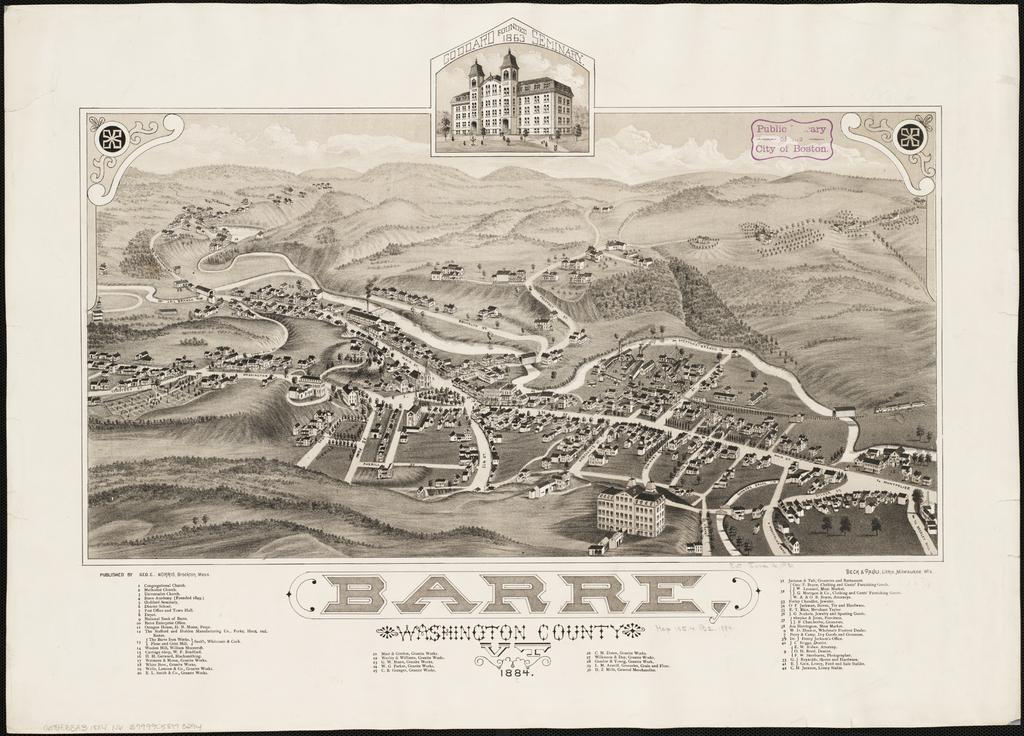<image>
Create a compact narrative representing the image presented. A poster showing a depiction of the town of Barre in Washington County. 